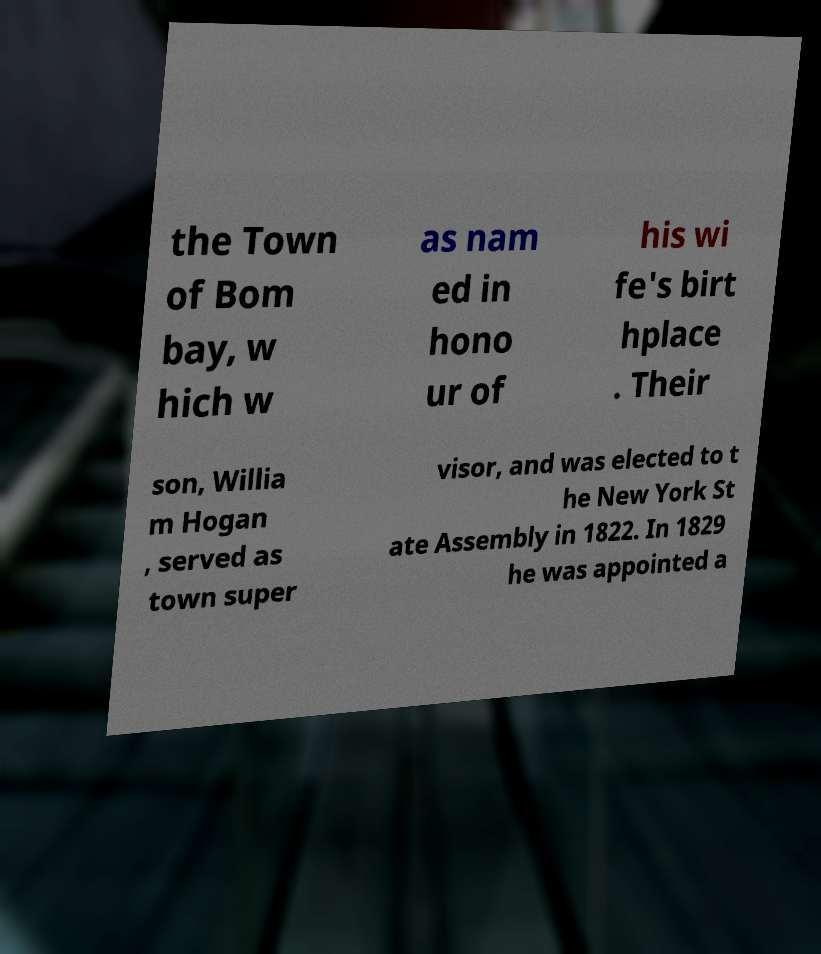I need the written content from this picture converted into text. Can you do that? the Town of Bom bay, w hich w as nam ed in hono ur of his wi fe's birt hplace . Their son, Willia m Hogan , served as town super visor, and was elected to t he New York St ate Assembly in 1822. In 1829 he was appointed a 